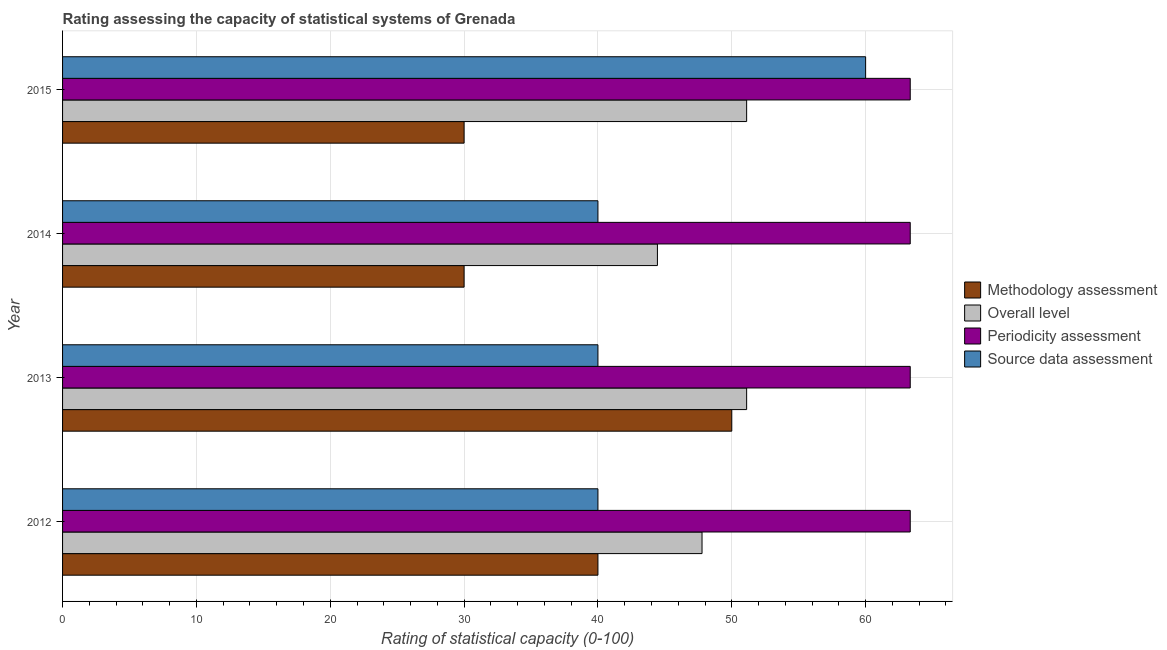How many different coloured bars are there?
Provide a short and direct response. 4. How many groups of bars are there?
Your answer should be very brief. 4. Are the number of bars on each tick of the Y-axis equal?
Keep it short and to the point. Yes. How many bars are there on the 4th tick from the bottom?
Give a very brief answer. 4. What is the label of the 4th group of bars from the top?
Your answer should be compact. 2012. What is the overall level rating in 2012?
Make the answer very short. 47.78. Across all years, what is the maximum source data assessment rating?
Your answer should be very brief. 60. Across all years, what is the minimum periodicity assessment rating?
Make the answer very short. 63.33. What is the total source data assessment rating in the graph?
Ensure brevity in your answer.  180. What is the difference between the source data assessment rating in 2012 and that in 2015?
Your answer should be very brief. -20. What is the difference between the periodicity assessment rating in 2012 and the overall level rating in 2014?
Offer a very short reply. 18.89. What is the average overall level rating per year?
Your answer should be very brief. 48.61. In the year 2015, what is the difference between the overall level rating and periodicity assessment rating?
Provide a succinct answer. -12.22. In how many years, is the overall level rating greater than 14 ?
Your response must be concise. 4. What is the ratio of the overall level rating in 2013 to that in 2014?
Offer a very short reply. 1.15. What is the difference between the highest and the second highest periodicity assessment rating?
Give a very brief answer. 0. What is the difference between the highest and the lowest methodology assessment rating?
Offer a very short reply. 20. In how many years, is the periodicity assessment rating greater than the average periodicity assessment rating taken over all years?
Provide a succinct answer. 1. Is the sum of the periodicity assessment rating in 2012 and 2015 greater than the maximum overall level rating across all years?
Offer a very short reply. Yes. Is it the case that in every year, the sum of the methodology assessment rating and periodicity assessment rating is greater than the sum of source data assessment rating and overall level rating?
Your response must be concise. Yes. What does the 3rd bar from the top in 2012 represents?
Provide a succinct answer. Overall level. What does the 3rd bar from the bottom in 2015 represents?
Your answer should be very brief. Periodicity assessment. Are all the bars in the graph horizontal?
Offer a very short reply. Yes. How many years are there in the graph?
Your answer should be compact. 4. Are the values on the major ticks of X-axis written in scientific E-notation?
Offer a very short reply. No. Where does the legend appear in the graph?
Keep it short and to the point. Center right. How many legend labels are there?
Keep it short and to the point. 4. What is the title of the graph?
Provide a succinct answer. Rating assessing the capacity of statistical systems of Grenada. Does "Secondary vocational education" appear as one of the legend labels in the graph?
Make the answer very short. No. What is the label or title of the X-axis?
Offer a very short reply. Rating of statistical capacity (0-100). What is the Rating of statistical capacity (0-100) in Methodology assessment in 2012?
Your response must be concise. 40. What is the Rating of statistical capacity (0-100) of Overall level in 2012?
Your answer should be compact. 47.78. What is the Rating of statistical capacity (0-100) of Periodicity assessment in 2012?
Your response must be concise. 63.33. What is the Rating of statistical capacity (0-100) in Source data assessment in 2012?
Keep it short and to the point. 40. What is the Rating of statistical capacity (0-100) of Methodology assessment in 2013?
Provide a succinct answer. 50. What is the Rating of statistical capacity (0-100) of Overall level in 2013?
Provide a succinct answer. 51.11. What is the Rating of statistical capacity (0-100) of Periodicity assessment in 2013?
Offer a terse response. 63.33. What is the Rating of statistical capacity (0-100) in Source data assessment in 2013?
Provide a short and direct response. 40. What is the Rating of statistical capacity (0-100) of Overall level in 2014?
Make the answer very short. 44.44. What is the Rating of statistical capacity (0-100) in Periodicity assessment in 2014?
Give a very brief answer. 63.33. What is the Rating of statistical capacity (0-100) of Methodology assessment in 2015?
Your response must be concise. 30. What is the Rating of statistical capacity (0-100) of Overall level in 2015?
Ensure brevity in your answer.  51.11. What is the Rating of statistical capacity (0-100) of Periodicity assessment in 2015?
Provide a short and direct response. 63.33. What is the Rating of statistical capacity (0-100) of Source data assessment in 2015?
Offer a very short reply. 60. Across all years, what is the maximum Rating of statistical capacity (0-100) in Overall level?
Keep it short and to the point. 51.11. Across all years, what is the maximum Rating of statistical capacity (0-100) in Periodicity assessment?
Ensure brevity in your answer.  63.33. Across all years, what is the maximum Rating of statistical capacity (0-100) of Source data assessment?
Provide a short and direct response. 60. Across all years, what is the minimum Rating of statistical capacity (0-100) in Overall level?
Make the answer very short. 44.44. Across all years, what is the minimum Rating of statistical capacity (0-100) of Periodicity assessment?
Provide a short and direct response. 63.33. What is the total Rating of statistical capacity (0-100) of Methodology assessment in the graph?
Keep it short and to the point. 150. What is the total Rating of statistical capacity (0-100) of Overall level in the graph?
Give a very brief answer. 194.44. What is the total Rating of statistical capacity (0-100) of Periodicity assessment in the graph?
Ensure brevity in your answer.  253.33. What is the total Rating of statistical capacity (0-100) of Source data assessment in the graph?
Your answer should be compact. 180. What is the difference between the Rating of statistical capacity (0-100) in Overall level in 2012 and that in 2013?
Your answer should be very brief. -3.33. What is the difference between the Rating of statistical capacity (0-100) of Periodicity assessment in 2012 and that in 2013?
Offer a terse response. -0. What is the difference between the Rating of statistical capacity (0-100) of Methodology assessment in 2012 and that in 2014?
Make the answer very short. 10. What is the difference between the Rating of statistical capacity (0-100) in Overall level in 2012 and that in 2014?
Keep it short and to the point. 3.33. What is the difference between the Rating of statistical capacity (0-100) of Periodicity assessment in 2012 and that in 2014?
Ensure brevity in your answer.  -0. What is the difference between the Rating of statistical capacity (0-100) of Source data assessment in 2012 and that in 2014?
Your response must be concise. 0. What is the difference between the Rating of statistical capacity (0-100) of Methodology assessment in 2012 and that in 2015?
Provide a short and direct response. 10. What is the difference between the Rating of statistical capacity (0-100) in Overall level in 2012 and that in 2015?
Offer a terse response. -3.33. What is the difference between the Rating of statistical capacity (0-100) of Periodicity assessment in 2012 and that in 2015?
Offer a terse response. -0. What is the difference between the Rating of statistical capacity (0-100) of Source data assessment in 2012 and that in 2015?
Give a very brief answer. -20. What is the difference between the Rating of statistical capacity (0-100) in Overall level in 2013 and that in 2014?
Ensure brevity in your answer.  6.67. What is the difference between the Rating of statistical capacity (0-100) in Periodicity assessment in 2013 and that in 2015?
Your answer should be very brief. -0. What is the difference between the Rating of statistical capacity (0-100) in Source data assessment in 2013 and that in 2015?
Provide a succinct answer. -20. What is the difference between the Rating of statistical capacity (0-100) in Overall level in 2014 and that in 2015?
Offer a very short reply. -6.67. What is the difference between the Rating of statistical capacity (0-100) in Periodicity assessment in 2014 and that in 2015?
Your answer should be compact. -0. What is the difference between the Rating of statistical capacity (0-100) of Methodology assessment in 2012 and the Rating of statistical capacity (0-100) of Overall level in 2013?
Provide a short and direct response. -11.11. What is the difference between the Rating of statistical capacity (0-100) of Methodology assessment in 2012 and the Rating of statistical capacity (0-100) of Periodicity assessment in 2013?
Keep it short and to the point. -23.33. What is the difference between the Rating of statistical capacity (0-100) in Methodology assessment in 2012 and the Rating of statistical capacity (0-100) in Source data assessment in 2013?
Your answer should be very brief. 0. What is the difference between the Rating of statistical capacity (0-100) of Overall level in 2012 and the Rating of statistical capacity (0-100) of Periodicity assessment in 2013?
Make the answer very short. -15.56. What is the difference between the Rating of statistical capacity (0-100) of Overall level in 2012 and the Rating of statistical capacity (0-100) of Source data assessment in 2013?
Offer a very short reply. 7.78. What is the difference between the Rating of statistical capacity (0-100) of Periodicity assessment in 2012 and the Rating of statistical capacity (0-100) of Source data assessment in 2013?
Make the answer very short. 23.33. What is the difference between the Rating of statistical capacity (0-100) in Methodology assessment in 2012 and the Rating of statistical capacity (0-100) in Overall level in 2014?
Keep it short and to the point. -4.44. What is the difference between the Rating of statistical capacity (0-100) in Methodology assessment in 2012 and the Rating of statistical capacity (0-100) in Periodicity assessment in 2014?
Your answer should be very brief. -23.33. What is the difference between the Rating of statistical capacity (0-100) in Methodology assessment in 2012 and the Rating of statistical capacity (0-100) in Source data assessment in 2014?
Offer a very short reply. 0. What is the difference between the Rating of statistical capacity (0-100) in Overall level in 2012 and the Rating of statistical capacity (0-100) in Periodicity assessment in 2014?
Your answer should be compact. -15.56. What is the difference between the Rating of statistical capacity (0-100) of Overall level in 2012 and the Rating of statistical capacity (0-100) of Source data assessment in 2014?
Give a very brief answer. 7.78. What is the difference between the Rating of statistical capacity (0-100) in Periodicity assessment in 2012 and the Rating of statistical capacity (0-100) in Source data assessment in 2014?
Give a very brief answer. 23.33. What is the difference between the Rating of statistical capacity (0-100) in Methodology assessment in 2012 and the Rating of statistical capacity (0-100) in Overall level in 2015?
Give a very brief answer. -11.11. What is the difference between the Rating of statistical capacity (0-100) in Methodology assessment in 2012 and the Rating of statistical capacity (0-100) in Periodicity assessment in 2015?
Give a very brief answer. -23.33. What is the difference between the Rating of statistical capacity (0-100) of Overall level in 2012 and the Rating of statistical capacity (0-100) of Periodicity assessment in 2015?
Your answer should be very brief. -15.56. What is the difference between the Rating of statistical capacity (0-100) in Overall level in 2012 and the Rating of statistical capacity (0-100) in Source data assessment in 2015?
Offer a very short reply. -12.22. What is the difference between the Rating of statistical capacity (0-100) in Periodicity assessment in 2012 and the Rating of statistical capacity (0-100) in Source data assessment in 2015?
Offer a very short reply. 3.33. What is the difference between the Rating of statistical capacity (0-100) in Methodology assessment in 2013 and the Rating of statistical capacity (0-100) in Overall level in 2014?
Provide a short and direct response. 5.56. What is the difference between the Rating of statistical capacity (0-100) in Methodology assessment in 2013 and the Rating of statistical capacity (0-100) in Periodicity assessment in 2014?
Provide a short and direct response. -13.33. What is the difference between the Rating of statistical capacity (0-100) in Methodology assessment in 2013 and the Rating of statistical capacity (0-100) in Source data assessment in 2014?
Provide a succinct answer. 10. What is the difference between the Rating of statistical capacity (0-100) of Overall level in 2013 and the Rating of statistical capacity (0-100) of Periodicity assessment in 2014?
Provide a succinct answer. -12.22. What is the difference between the Rating of statistical capacity (0-100) in Overall level in 2013 and the Rating of statistical capacity (0-100) in Source data assessment in 2014?
Your response must be concise. 11.11. What is the difference between the Rating of statistical capacity (0-100) in Periodicity assessment in 2013 and the Rating of statistical capacity (0-100) in Source data assessment in 2014?
Give a very brief answer. 23.33. What is the difference between the Rating of statistical capacity (0-100) in Methodology assessment in 2013 and the Rating of statistical capacity (0-100) in Overall level in 2015?
Make the answer very short. -1.11. What is the difference between the Rating of statistical capacity (0-100) in Methodology assessment in 2013 and the Rating of statistical capacity (0-100) in Periodicity assessment in 2015?
Your response must be concise. -13.33. What is the difference between the Rating of statistical capacity (0-100) of Methodology assessment in 2013 and the Rating of statistical capacity (0-100) of Source data assessment in 2015?
Give a very brief answer. -10. What is the difference between the Rating of statistical capacity (0-100) in Overall level in 2013 and the Rating of statistical capacity (0-100) in Periodicity assessment in 2015?
Offer a very short reply. -12.22. What is the difference between the Rating of statistical capacity (0-100) in Overall level in 2013 and the Rating of statistical capacity (0-100) in Source data assessment in 2015?
Make the answer very short. -8.89. What is the difference between the Rating of statistical capacity (0-100) of Periodicity assessment in 2013 and the Rating of statistical capacity (0-100) of Source data assessment in 2015?
Provide a succinct answer. 3.33. What is the difference between the Rating of statistical capacity (0-100) in Methodology assessment in 2014 and the Rating of statistical capacity (0-100) in Overall level in 2015?
Give a very brief answer. -21.11. What is the difference between the Rating of statistical capacity (0-100) of Methodology assessment in 2014 and the Rating of statistical capacity (0-100) of Periodicity assessment in 2015?
Your answer should be very brief. -33.33. What is the difference between the Rating of statistical capacity (0-100) in Overall level in 2014 and the Rating of statistical capacity (0-100) in Periodicity assessment in 2015?
Offer a very short reply. -18.89. What is the difference between the Rating of statistical capacity (0-100) of Overall level in 2014 and the Rating of statistical capacity (0-100) of Source data assessment in 2015?
Provide a succinct answer. -15.56. What is the difference between the Rating of statistical capacity (0-100) in Periodicity assessment in 2014 and the Rating of statistical capacity (0-100) in Source data assessment in 2015?
Make the answer very short. 3.33. What is the average Rating of statistical capacity (0-100) of Methodology assessment per year?
Offer a terse response. 37.5. What is the average Rating of statistical capacity (0-100) of Overall level per year?
Offer a terse response. 48.61. What is the average Rating of statistical capacity (0-100) of Periodicity assessment per year?
Make the answer very short. 63.33. What is the average Rating of statistical capacity (0-100) in Source data assessment per year?
Give a very brief answer. 45. In the year 2012, what is the difference between the Rating of statistical capacity (0-100) of Methodology assessment and Rating of statistical capacity (0-100) of Overall level?
Offer a terse response. -7.78. In the year 2012, what is the difference between the Rating of statistical capacity (0-100) of Methodology assessment and Rating of statistical capacity (0-100) of Periodicity assessment?
Ensure brevity in your answer.  -23.33. In the year 2012, what is the difference between the Rating of statistical capacity (0-100) in Overall level and Rating of statistical capacity (0-100) in Periodicity assessment?
Offer a terse response. -15.56. In the year 2012, what is the difference between the Rating of statistical capacity (0-100) in Overall level and Rating of statistical capacity (0-100) in Source data assessment?
Offer a terse response. 7.78. In the year 2012, what is the difference between the Rating of statistical capacity (0-100) in Periodicity assessment and Rating of statistical capacity (0-100) in Source data assessment?
Provide a succinct answer. 23.33. In the year 2013, what is the difference between the Rating of statistical capacity (0-100) in Methodology assessment and Rating of statistical capacity (0-100) in Overall level?
Your answer should be compact. -1.11. In the year 2013, what is the difference between the Rating of statistical capacity (0-100) of Methodology assessment and Rating of statistical capacity (0-100) of Periodicity assessment?
Ensure brevity in your answer.  -13.33. In the year 2013, what is the difference between the Rating of statistical capacity (0-100) in Overall level and Rating of statistical capacity (0-100) in Periodicity assessment?
Ensure brevity in your answer.  -12.22. In the year 2013, what is the difference between the Rating of statistical capacity (0-100) of Overall level and Rating of statistical capacity (0-100) of Source data assessment?
Offer a very short reply. 11.11. In the year 2013, what is the difference between the Rating of statistical capacity (0-100) in Periodicity assessment and Rating of statistical capacity (0-100) in Source data assessment?
Give a very brief answer. 23.33. In the year 2014, what is the difference between the Rating of statistical capacity (0-100) in Methodology assessment and Rating of statistical capacity (0-100) in Overall level?
Ensure brevity in your answer.  -14.44. In the year 2014, what is the difference between the Rating of statistical capacity (0-100) in Methodology assessment and Rating of statistical capacity (0-100) in Periodicity assessment?
Make the answer very short. -33.33. In the year 2014, what is the difference between the Rating of statistical capacity (0-100) of Overall level and Rating of statistical capacity (0-100) of Periodicity assessment?
Provide a short and direct response. -18.89. In the year 2014, what is the difference between the Rating of statistical capacity (0-100) of Overall level and Rating of statistical capacity (0-100) of Source data assessment?
Offer a very short reply. 4.44. In the year 2014, what is the difference between the Rating of statistical capacity (0-100) in Periodicity assessment and Rating of statistical capacity (0-100) in Source data assessment?
Keep it short and to the point. 23.33. In the year 2015, what is the difference between the Rating of statistical capacity (0-100) of Methodology assessment and Rating of statistical capacity (0-100) of Overall level?
Keep it short and to the point. -21.11. In the year 2015, what is the difference between the Rating of statistical capacity (0-100) of Methodology assessment and Rating of statistical capacity (0-100) of Periodicity assessment?
Keep it short and to the point. -33.33. In the year 2015, what is the difference between the Rating of statistical capacity (0-100) of Methodology assessment and Rating of statistical capacity (0-100) of Source data assessment?
Your answer should be very brief. -30. In the year 2015, what is the difference between the Rating of statistical capacity (0-100) in Overall level and Rating of statistical capacity (0-100) in Periodicity assessment?
Provide a succinct answer. -12.22. In the year 2015, what is the difference between the Rating of statistical capacity (0-100) of Overall level and Rating of statistical capacity (0-100) of Source data assessment?
Provide a succinct answer. -8.89. In the year 2015, what is the difference between the Rating of statistical capacity (0-100) in Periodicity assessment and Rating of statistical capacity (0-100) in Source data assessment?
Your response must be concise. 3.33. What is the ratio of the Rating of statistical capacity (0-100) in Methodology assessment in 2012 to that in 2013?
Ensure brevity in your answer.  0.8. What is the ratio of the Rating of statistical capacity (0-100) of Overall level in 2012 to that in 2013?
Offer a very short reply. 0.93. What is the ratio of the Rating of statistical capacity (0-100) in Source data assessment in 2012 to that in 2013?
Offer a terse response. 1. What is the ratio of the Rating of statistical capacity (0-100) of Overall level in 2012 to that in 2014?
Your answer should be very brief. 1.07. What is the ratio of the Rating of statistical capacity (0-100) of Source data assessment in 2012 to that in 2014?
Your response must be concise. 1. What is the ratio of the Rating of statistical capacity (0-100) in Overall level in 2012 to that in 2015?
Keep it short and to the point. 0.93. What is the ratio of the Rating of statistical capacity (0-100) of Periodicity assessment in 2012 to that in 2015?
Keep it short and to the point. 1. What is the ratio of the Rating of statistical capacity (0-100) in Source data assessment in 2012 to that in 2015?
Your response must be concise. 0.67. What is the ratio of the Rating of statistical capacity (0-100) of Overall level in 2013 to that in 2014?
Offer a very short reply. 1.15. What is the ratio of the Rating of statistical capacity (0-100) of Overall level in 2013 to that in 2015?
Your response must be concise. 1. What is the ratio of the Rating of statistical capacity (0-100) in Periodicity assessment in 2013 to that in 2015?
Provide a short and direct response. 1. What is the ratio of the Rating of statistical capacity (0-100) of Overall level in 2014 to that in 2015?
Provide a short and direct response. 0.87. What is the ratio of the Rating of statistical capacity (0-100) of Periodicity assessment in 2014 to that in 2015?
Provide a succinct answer. 1. What is the ratio of the Rating of statistical capacity (0-100) of Source data assessment in 2014 to that in 2015?
Provide a short and direct response. 0.67. What is the difference between the highest and the second highest Rating of statistical capacity (0-100) of Periodicity assessment?
Keep it short and to the point. 0. What is the difference between the highest and the lowest Rating of statistical capacity (0-100) of Methodology assessment?
Provide a short and direct response. 20. What is the difference between the highest and the lowest Rating of statistical capacity (0-100) of Periodicity assessment?
Your response must be concise. 0. What is the difference between the highest and the lowest Rating of statistical capacity (0-100) in Source data assessment?
Your answer should be very brief. 20. 